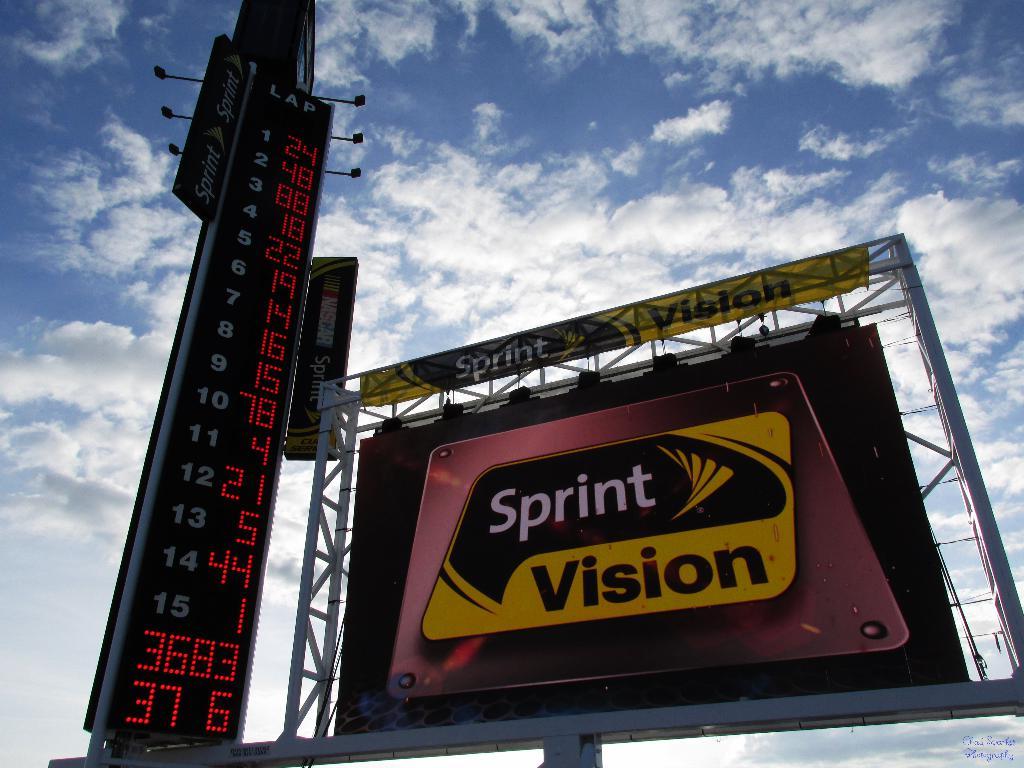What number is indicated next to lap 3?
Your response must be concise. 88. What is the tall black sign counting?
Offer a very short reply. Lap. 